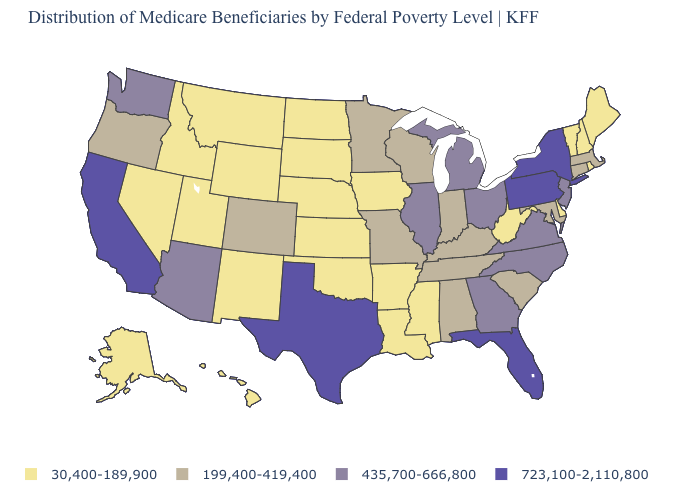What is the lowest value in the Northeast?
Write a very short answer. 30,400-189,900. Among the states that border Nevada , which have the lowest value?
Write a very short answer. Idaho, Utah. Among the states that border Delaware , which have the highest value?
Quick response, please. Pennsylvania. What is the value of Arizona?
Concise answer only. 435,700-666,800. What is the value of Illinois?
Give a very brief answer. 435,700-666,800. Does the map have missing data?
Quick response, please. No. What is the value of Colorado?
Answer briefly. 199,400-419,400. Among the states that border Pennsylvania , does Maryland have the highest value?
Answer briefly. No. Does the first symbol in the legend represent the smallest category?
Be succinct. Yes. Does Massachusetts have the same value as Alabama?
Give a very brief answer. Yes. Which states have the lowest value in the West?
Concise answer only. Alaska, Hawaii, Idaho, Montana, Nevada, New Mexico, Utah, Wyoming. What is the value of New York?
Quick response, please. 723,100-2,110,800. Which states have the highest value in the USA?
Be succinct. California, Florida, New York, Pennsylvania, Texas. Name the states that have a value in the range 723,100-2,110,800?
Give a very brief answer. California, Florida, New York, Pennsylvania, Texas. Among the states that border Massachusetts , does Connecticut have the highest value?
Give a very brief answer. No. 